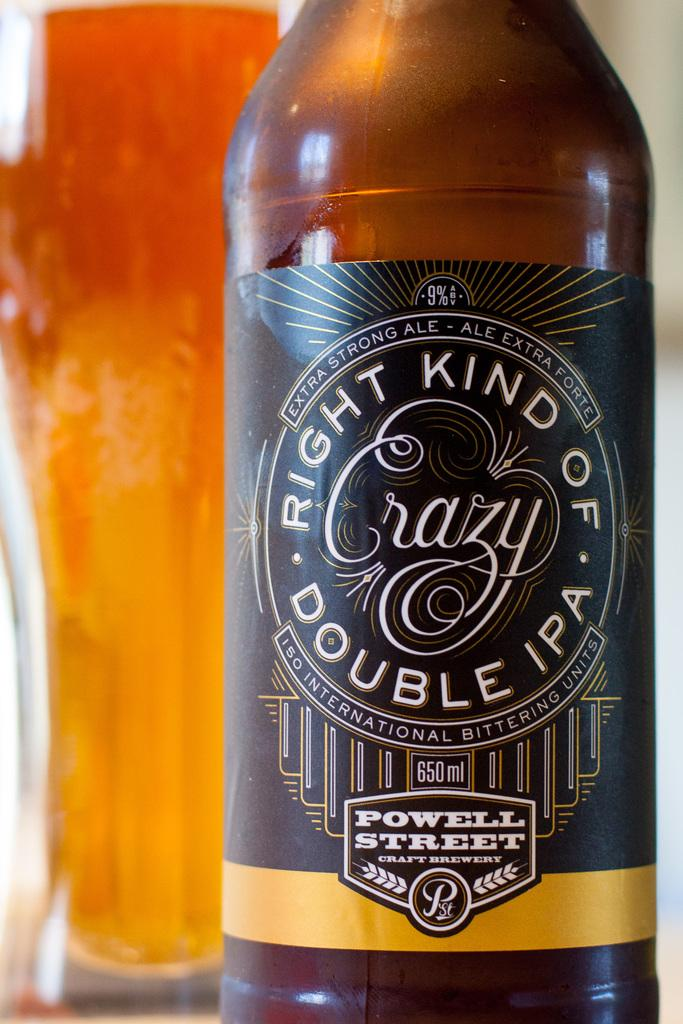What is the main object in the image? There is a wine bottle in the image. What colors can be seen on the wine bottle? The wine bottle has brown and black colors. How would you describe the background of the image? The background of the image has orange and red colors. What type of chain is attached to the wine bottle in the image? There is no chain attached to the wine bottle in the image. What condition is the spade in, as seen in the image? There is no spade present in the image. 